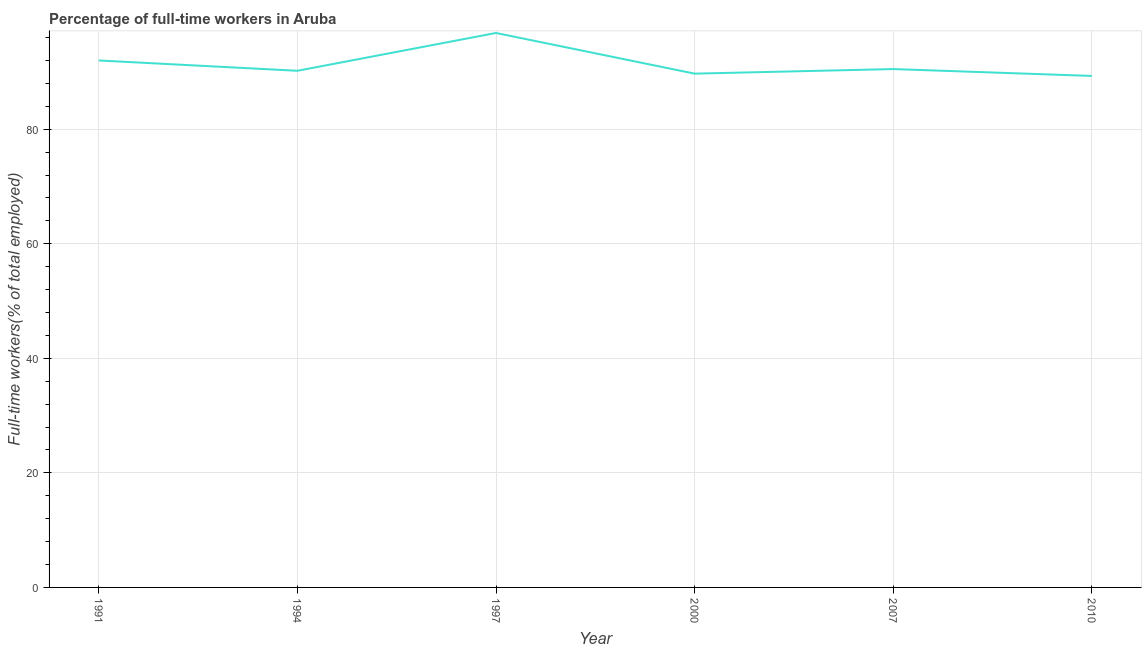What is the percentage of full-time workers in 2010?
Keep it short and to the point. 89.3. Across all years, what is the maximum percentage of full-time workers?
Give a very brief answer. 96.8. Across all years, what is the minimum percentage of full-time workers?
Offer a terse response. 89.3. In which year was the percentage of full-time workers minimum?
Your answer should be compact. 2010. What is the sum of the percentage of full-time workers?
Provide a short and direct response. 548.5. What is the difference between the percentage of full-time workers in 1991 and 2007?
Give a very brief answer. 1.5. What is the average percentage of full-time workers per year?
Provide a short and direct response. 91.42. What is the median percentage of full-time workers?
Keep it short and to the point. 90.35. In how many years, is the percentage of full-time workers greater than 76 %?
Your answer should be very brief. 6. What is the ratio of the percentage of full-time workers in 2000 to that in 2010?
Make the answer very short. 1. Is the percentage of full-time workers in 1997 less than that in 2007?
Keep it short and to the point. No. What is the difference between the highest and the second highest percentage of full-time workers?
Offer a very short reply. 4.8. What is the difference between the highest and the lowest percentage of full-time workers?
Offer a very short reply. 7.5. In how many years, is the percentage of full-time workers greater than the average percentage of full-time workers taken over all years?
Give a very brief answer. 2. Does the percentage of full-time workers monotonically increase over the years?
Provide a succinct answer. No. How many lines are there?
Provide a succinct answer. 1. How many years are there in the graph?
Provide a succinct answer. 6. What is the difference between two consecutive major ticks on the Y-axis?
Keep it short and to the point. 20. Does the graph contain any zero values?
Ensure brevity in your answer.  No. What is the title of the graph?
Provide a succinct answer. Percentage of full-time workers in Aruba. What is the label or title of the X-axis?
Give a very brief answer. Year. What is the label or title of the Y-axis?
Your answer should be very brief. Full-time workers(% of total employed). What is the Full-time workers(% of total employed) of 1991?
Make the answer very short. 92. What is the Full-time workers(% of total employed) of 1994?
Provide a short and direct response. 90.2. What is the Full-time workers(% of total employed) in 1997?
Your response must be concise. 96.8. What is the Full-time workers(% of total employed) in 2000?
Give a very brief answer. 89.7. What is the Full-time workers(% of total employed) in 2007?
Ensure brevity in your answer.  90.5. What is the Full-time workers(% of total employed) in 2010?
Provide a succinct answer. 89.3. What is the difference between the Full-time workers(% of total employed) in 1991 and 1994?
Your answer should be very brief. 1.8. What is the difference between the Full-time workers(% of total employed) in 1991 and 1997?
Keep it short and to the point. -4.8. What is the difference between the Full-time workers(% of total employed) in 1991 and 2010?
Offer a terse response. 2.7. What is the difference between the Full-time workers(% of total employed) in 1994 and 1997?
Your response must be concise. -6.6. What is the difference between the Full-time workers(% of total employed) in 1994 and 2007?
Your answer should be compact. -0.3. What is the difference between the Full-time workers(% of total employed) in 1994 and 2010?
Your answer should be compact. 0.9. What is the difference between the Full-time workers(% of total employed) in 1997 and 2000?
Make the answer very short. 7.1. What is the difference between the Full-time workers(% of total employed) in 1997 and 2007?
Offer a very short reply. 6.3. What is the difference between the Full-time workers(% of total employed) in 1997 and 2010?
Provide a short and direct response. 7.5. What is the difference between the Full-time workers(% of total employed) in 2000 and 2010?
Provide a succinct answer. 0.4. What is the difference between the Full-time workers(% of total employed) in 2007 and 2010?
Your response must be concise. 1.2. What is the ratio of the Full-time workers(% of total employed) in 1991 to that in 1994?
Your answer should be very brief. 1.02. What is the ratio of the Full-time workers(% of total employed) in 1991 to that in 1997?
Make the answer very short. 0.95. What is the ratio of the Full-time workers(% of total employed) in 1991 to that in 2000?
Offer a terse response. 1.03. What is the ratio of the Full-time workers(% of total employed) in 1994 to that in 1997?
Offer a terse response. 0.93. What is the ratio of the Full-time workers(% of total employed) in 1994 to that in 2000?
Give a very brief answer. 1.01. What is the ratio of the Full-time workers(% of total employed) in 1994 to that in 2010?
Provide a succinct answer. 1.01. What is the ratio of the Full-time workers(% of total employed) in 1997 to that in 2000?
Give a very brief answer. 1.08. What is the ratio of the Full-time workers(% of total employed) in 1997 to that in 2007?
Provide a short and direct response. 1.07. What is the ratio of the Full-time workers(% of total employed) in 1997 to that in 2010?
Offer a terse response. 1.08. 